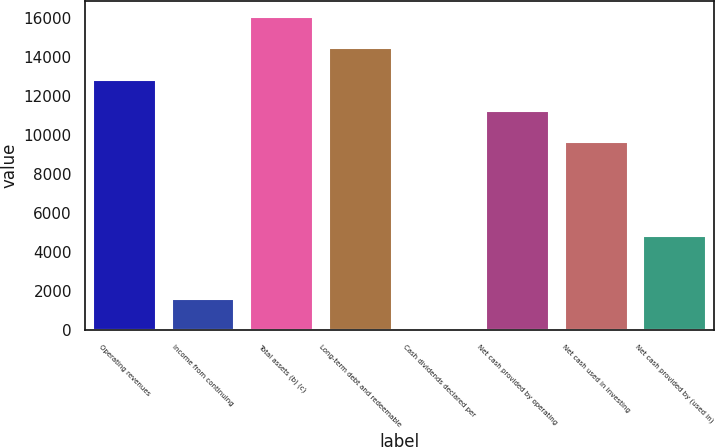Convert chart. <chart><loc_0><loc_0><loc_500><loc_500><bar_chart><fcel>Operating revenues<fcel>Income from continuing<fcel>Total assets (b) (c)<fcel>Long-term debt and redeemable<fcel>Cash dividends declared per<fcel>Net cash provided by operating<fcel>Net cash used in investing<fcel>Net cash provided by (used in)<nl><fcel>12830.7<fcel>1604.92<fcel>16038<fcel>14434.4<fcel>1.24<fcel>11227<fcel>9623.32<fcel>4812.28<nl></chart> 